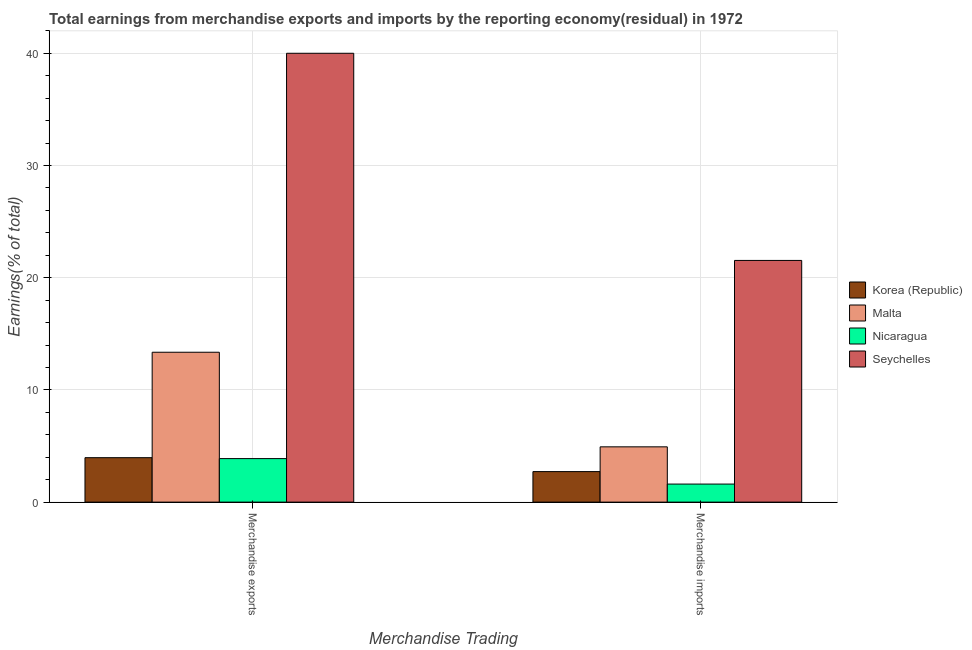How many groups of bars are there?
Your answer should be compact. 2. Are the number of bars per tick equal to the number of legend labels?
Make the answer very short. Yes. Are the number of bars on each tick of the X-axis equal?
Your answer should be very brief. Yes. How many bars are there on the 2nd tick from the right?
Your response must be concise. 4. What is the label of the 1st group of bars from the left?
Your answer should be compact. Merchandise exports. What is the earnings from merchandise imports in Seychelles?
Offer a very short reply. 21.54. Across all countries, what is the maximum earnings from merchandise imports?
Provide a short and direct response. 21.54. Across all countries, what is the minimum earnings from merchandise exports?
Your answer should be compact. 3.88. In which country was the earnings from merchandise imports maximum?
Keep it short and to the point. Seychelles. In which country was the earnings from merchandise exports minimum?
Your answer should be very brief. Nicaragua. What is the total earnings from merchandise exports in the graph?
Provide a short and direct response. 61.2. What is the difference between the earnings from merchandise imports in Korea (Republic) and that in Malta?
Keep it short and to the point. -2.21. What is the difference between the earnings from merchandise imports in Seychelles and the earnings from merchandise exports in Malta?
Provide a short and direct response. 8.18. What is the average earnings from merchandise exports per country?
Give a very brief answer. 15.3. What is the difference between the earnings from merchandise imports and earnings from merchandise exports in Nicaragua?
Provide a short and direct response. -2.27. In how many countries, is the earnings from merchandise imports greater than 14 %?
Provide a succinct answer. 1. What is the ratio of the earnings from merchandise exports in Korea (Republic) to that in Nicaragua?
Give a very brief answer. 1.02. What does the 3rd bar from the left in Merchandise exports represents?
Your response must be concise. Nicaragua. What does the 3rd bar from the right in Merchandise imports represents?
Your answer should be compact. Malta. Are all the bars in the graph horizontal?
Provide a short and direct response. No. How many countries are there in the graph?
Offer a very short reply. 4. Are the values on the major ticks of Y-axis written in scientific E-notation?
Your answer should be compact. No. Does the graph contain grids?
Your answer should be compact. Yes. Where does the legend appear in the graph?
Provide a short and direct response. Center right. What is the title of the graph?
Provide a succinct answer. Total earnings from merchandise exports and imports by the reporting economy(residual) in 1972. Does "Sudan" appear as one of the legend labels in the graph?
Keep it short and to the point. No. What is the label or title of the X-axis?
Keep it short and to the point. Merchandise Trading. What is the label or title of the Y-axis?
Provide a succinct answer. Earnings(% of total). What is the Earnings(% of total) in Korea (Republic) in Merchandise exports?
Your response must be concise. 3.96. What is the Earnings(% of total) of Malta in Merchandise exports?
Provide a succinct answer. 13.36. What is the Earnings(% of total) in Nicaragua in Merchandise exports?
Provide a succinct answer. 3.88. What is the Earnings(% of total) of Seychelles in Merchandise exports?
Offer a terse response. 40. What is the Earnings(% of total) in Korea (Republic) in Merchandise imports?
Your response must be concise. 2.72. What is the Earnings(% of total) in Malta in Merchandise imports?
Provide a short and direct response. 4.93. What is the Earnings(% of total) of Nicaragua in Merchandise imports?
Offer a very short reply. 1.61. What is the Earnings(% of total) of Seychelles in Merchandise imports?
Provide a short and direct response. 21.54. Across all Merchandise Trading, what is the maximum Earnings(% of total) of Korea (Republic)?
Keep it short and to the point. 3.96. Across all Merchandise Trading, what is the maximum Earnings(% of total) in Malta?
Offer a terse response. 13.36. Across all Merchandise Trading, what is the maximum Earnings(% of total) of Nicaragua?
Your response must be concise. 3.88. Across all Merchandise Trading, what is the minimum Earnings(% of total) of Korea (Republic)?
Keep it short and to the point. 2.72. Across all Merchandise Trading, what is the minimum Earnings(% of total) in Malta?
Your answer should be very brief. 4.93. Across all Merchandise Trading, what is the minimum Earnings(% of total) of Nicaragua?
Provide a succinct answer. 1.61. Across all Merchandise Trading, what is the minimum Earnings(% of total) in Seychelles?
Provide a succinct answer. 21.54. What is the total Earnings(% of total) in Korea (Republic) in the graph?
Make the answer very short. 6.68. What is the total Earnings(% of total) in Malta in the graph?
Your answer should be very brief. 18.28. What is the total Earnings(% of total) in Nicaragua in the graph?
Make the answer very short. 5.49. What is the total Earnings(% of total) in Seychelles in the graph?
Make the answer very short. 61.54. What is the difference between the Earnings(% of total) in Korea (Republic) in Merchandise exports and that in Merchandise imports?
Make the answer very short. 1.24. What is the difference between the Earnings(% of total) of Malta in Merchandise exports and that in Merchandise imports?
Offer a very short reply. 8.43. What is the difference between the Earnings(% of total) in Nicaragua in Merchandise exports and that in Merchandise imports?
Keep it short and to the point. 2.27. What is the difference between the Earnings(% of total) of Seychelles in Merchandise exports and that in Merchandise imports?
Your answer should be very brief. 18.46. What is the difference between the Earnings(% of total) in Korea (Republic) in Merchandise exports and the Earnings(% of total) in Malta in Merchandise imports?
Provide a succinct answer. -0.97. What is the difference between the Earnings(% of total) in Korea (Republic) in Merchandise exports and the Earnings(% of total) in Nicaragua in Merchandise imports?
Offer a terse response. 2.35. What is the difference between the Earnings(% of total) in Korea (Republic) in Merchandise exports and the Earnings(% of total) in Seychelles in Merchandise imports?
Keep it short and to the point. -17.58. What is the difference between the Earnings(% of total) in Malta in Merchandise exports and the Earnings(% of total) in Nicaragua in Merchandise imports?
Provide a short and direct response. 11.75. What is the difference between the Earnings(% of total) of Malta in Merchandise exports and the Earnings(% of total) of Seychelles in Merchandise imports?
Ensure brevity in your answer.  -8.18. What is the difference between the Earnings(% of total) in Nicaragua in Merchandise exports and the Earnings(% of total) in Seychelles in Merchandise imports?
Provide a succinct answer. -17.66. What is the average Earnings(% of total) of Korea (Republic) per Merchandise Trading?
Your answer should be compact. 3.34. What is the average Earnings(% of total) of Malta per Merchandise Trading?
Your answer should be very brief. 9.14. What is the average Earnings(% of total) of Nicaragua per Merchandise Trading?
Ensure brevity in your answer.  2.74. What is the average Earnings(% of total) in Seychelles per Merchandise Trading?
Make the answer very short. 30.77. What is the difference between the Earnings(% of total) of Korea (Republic) and Earnings(% of total) of Malta in Merchandise exports?
Offer a terse response. -9.4. What is the difference between the Earnings(% of total) of Korea (Republic) and Earnings(% of total) of Nicaragua in Merchandise exports?
Offer a terse response. 0.08. What is the difference between the Earnings(% of total) in Korea (Republic) and Earnings(% of total) in Seychelles in Merchandise exports?
Give a very brief answer. -36.04. What is the difference between the Earnings(% of total) of Malta and Earnings(% of total) of Nicaragua in Merchandise exports?
Provide a succinct answer. 9.48. What is the difference between the Earnings(% of total) in Malta and Earnings(% of total) in Seychelles in Merchandise exports?
Your answer should be compact. -26.64. What is the difference between the Earnings(% of total) in Nicaragua and Earnings(% of total) in Seychelles in Merchandise exports?
Your answer should be very brief. -36.12. What is the difference between the Earnings(% of total) of Korea (Republic) and Earnings(% of total) of Malta in Merchandise imports?
Make the answer very short. -2.21. What is the difference between the Earnings(% of total) in Korea (Republic) and Earnings(% of total) in Nicaragua in Merchandise imports?
Your answer should be compact. 1.11. What is the difference between the Earnings(% of total) of Korea (Republic) and Earnings(% of total) of Seychelles in Merchandise imports?
Provide a short and direct response. -18.82. What is the difference between the Earnings(% of total) in Malta and Earnings(% of total) in Nicaragua in Merchandise imports?
Provide a short and direct response. 3.32. What is the difference between the Earnings(% of total) of Malta and Earnings(% of total) of Seychelles in Merchandise imports?
Provide a succinct answer. -16.61. What is the difference between the Earnings(% of total) of Nicaragua and Earnings(% of total) of Seychelles in Merchandise imports?
Your answer should be very brief. -19.93. What is the ratio of the Earnings(% of total) in Korea (Republic) in Merchandise exports to that in Merchandise imports?
Ensure brevity in your answer.  1.46. What is the ratio of the Earnings(% of total) in Malta in Merchandise exports to that in Merchandise imports?
Provide a short and direct response. 2.71. What is the ratio of the Earnings(% of total) of Nicaragua in Merchandise exports to that in Merchandise imports?
Your answer should be very brief. 2.41. What is the ratio of the Earnings(% of total) of Seychelles in Merchandise exports to that in Merchandise imports?
Ensure brevity in your answer.  1.86. What is the difference between the highest and the second highest Earnings(% of total) of Korea (Republic)?
Your answer should be compact. 1.24. What is the difference between the highest and the second highest Earnings(% of total) in Malta?
Your answer should be compact. 8.43. What is the difference between the highest and the second highest Earnings(% of total) of Nicaragua?
Offer a terse response. 2.27. What is the difference between the highest and the second highest Earnings(% of total) of Seychelles?
Provide a succinct answer. 18.46. What is the difference between the highest and the lowest Earnings(% of total) in Korea (Republic)?
Ensure brevity in your answer.  1.24. What is the difference between the highest and the lowest Earnings(% of total) in Malta?
Your answer should be very brief. 8.43. What is the difference between the highest and the lowest Earnings(% of total) in Nicaragua?
Make the answer very short. 2.27. What is the difference between the highest and the lowest Earnings(% of total) in Seychelles?
Offer a very short reply. 18.46. 